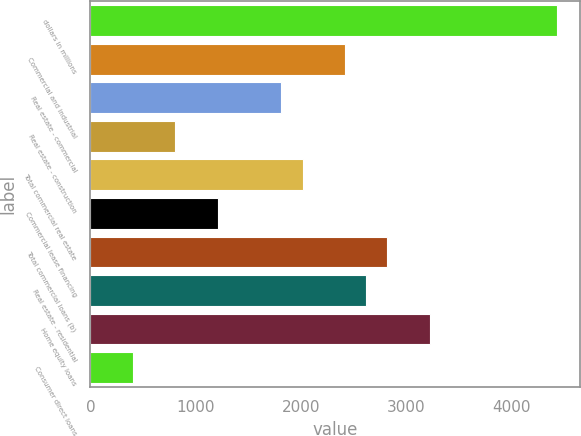Convert chart to OTSL. <chart><loc_0><loc_0><loc_500><loc_500><bar_chart><fcel>dollars in millions<fcel>Commercial and industrial<fcel>Real estate - commercial<fcel>Real estate - construction<fcel>Total commercial real estate<fcel>Commercial lease financing<fcel>Total commercial loans (b)<fcel>Real estate - residential<fcel>Home equity loans<fcel>Consumer direct loans<nl><fcel>4427.55<fcel>2415.45<fcel>1811.82<fcel>805.77<fcel>2013.03<fcel>1208.19<fcel>2817.87<fcel>2616.66<fcel>3220.29<fcel>403.35<nl></chart> 